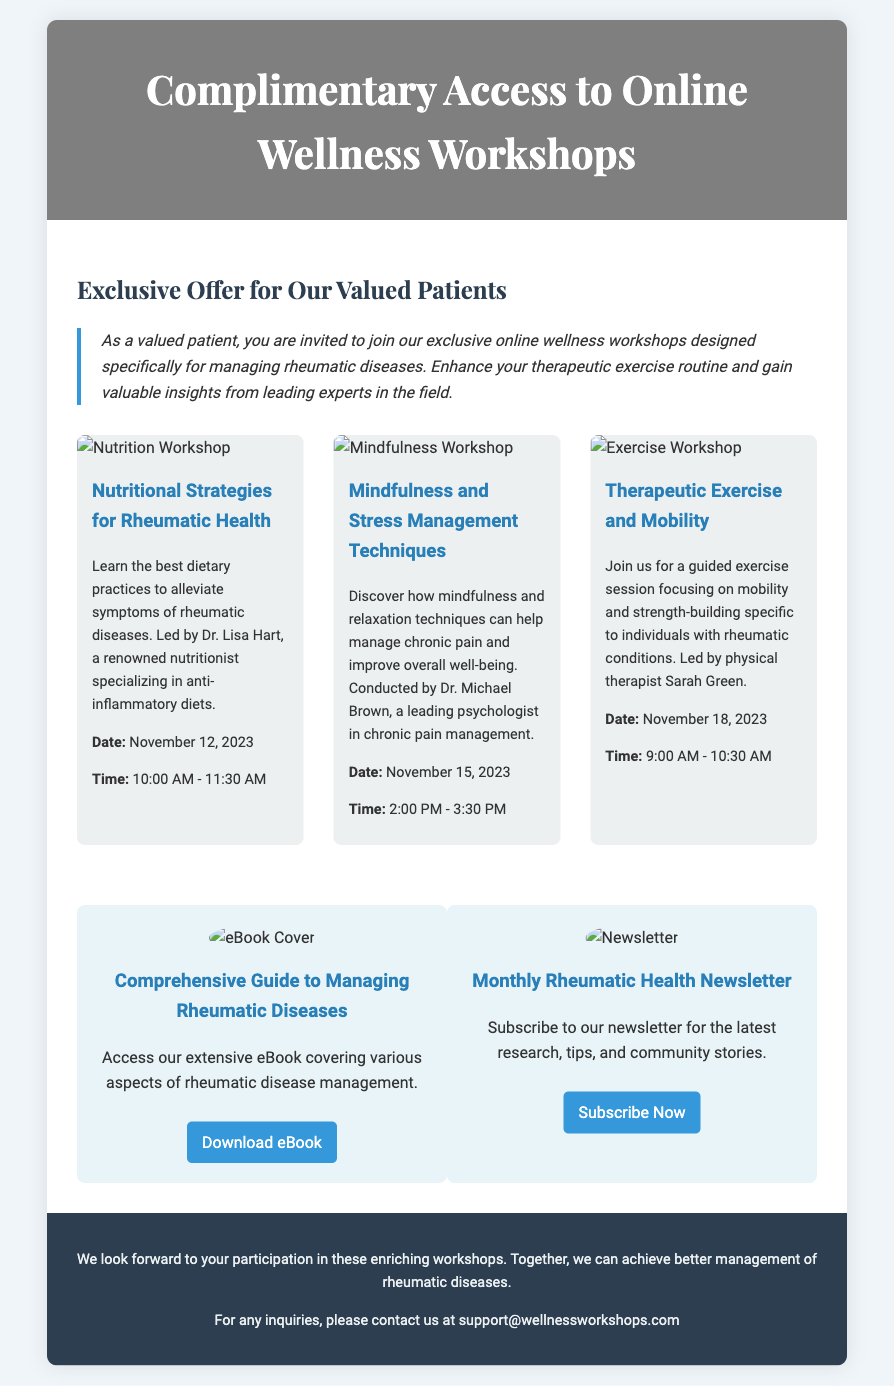what is the title of the workshops series? The title of the workshop series can be found in the header of the document, which states "Complimentary Access to Online Wellness Workshops".
Answer: Complimentary Access to Online Wellness Workshops who is the instructor for the nutritional strategies workshop? The instructor for the nutritional strategies workshop is mentioned in the workshop description as Dr. Lisa Hart.
Answer: Dr. Lisa Hart what is the date of the Therapeutic Exercise workshop? The date of the Therapeutic Exercise workshop is provided in the workshop details, specifically stating November 18, 2023.
Answer: November 18, 2023 how long is the Mindfulness workshop? The duration can be inferred from the start and end time provided, going from 2:00 PM to 3:30 PM, which is 1.5 hours.
Answer: 1.5 hours what is provided as a resource for managing rheumatic diseases? The document lists a resource, specifically an eBook, titled "Comprehensive Guide to Managing Rheumatic Diseases".
Answer: Comprehensive Guide to Managing Rheumatic Diseases what is the main purpose of the workshops? The main purpose is indicated in the invitation message, aiming to enhance therapeutic exercise routines and provide insights for managing rheumatic diseases.
Answer: Enhance therapeutic exercise routines what should patients do for inquiries about the workshops? The document provides a specific instruction for inquiries, which is to contact support@wellnessworkshops.com.
Answer: contact support@wellnessworkshops.com who leads the mindfulness and stress management techniques workshop? The workshop details specify that Dr. Michael Brown is the one leading this particular workshop.
Answer: Dr. Michael Brown how many workshops are listed in the document? The document lists a total of three workshops in the workshops section.
Answer: Three 